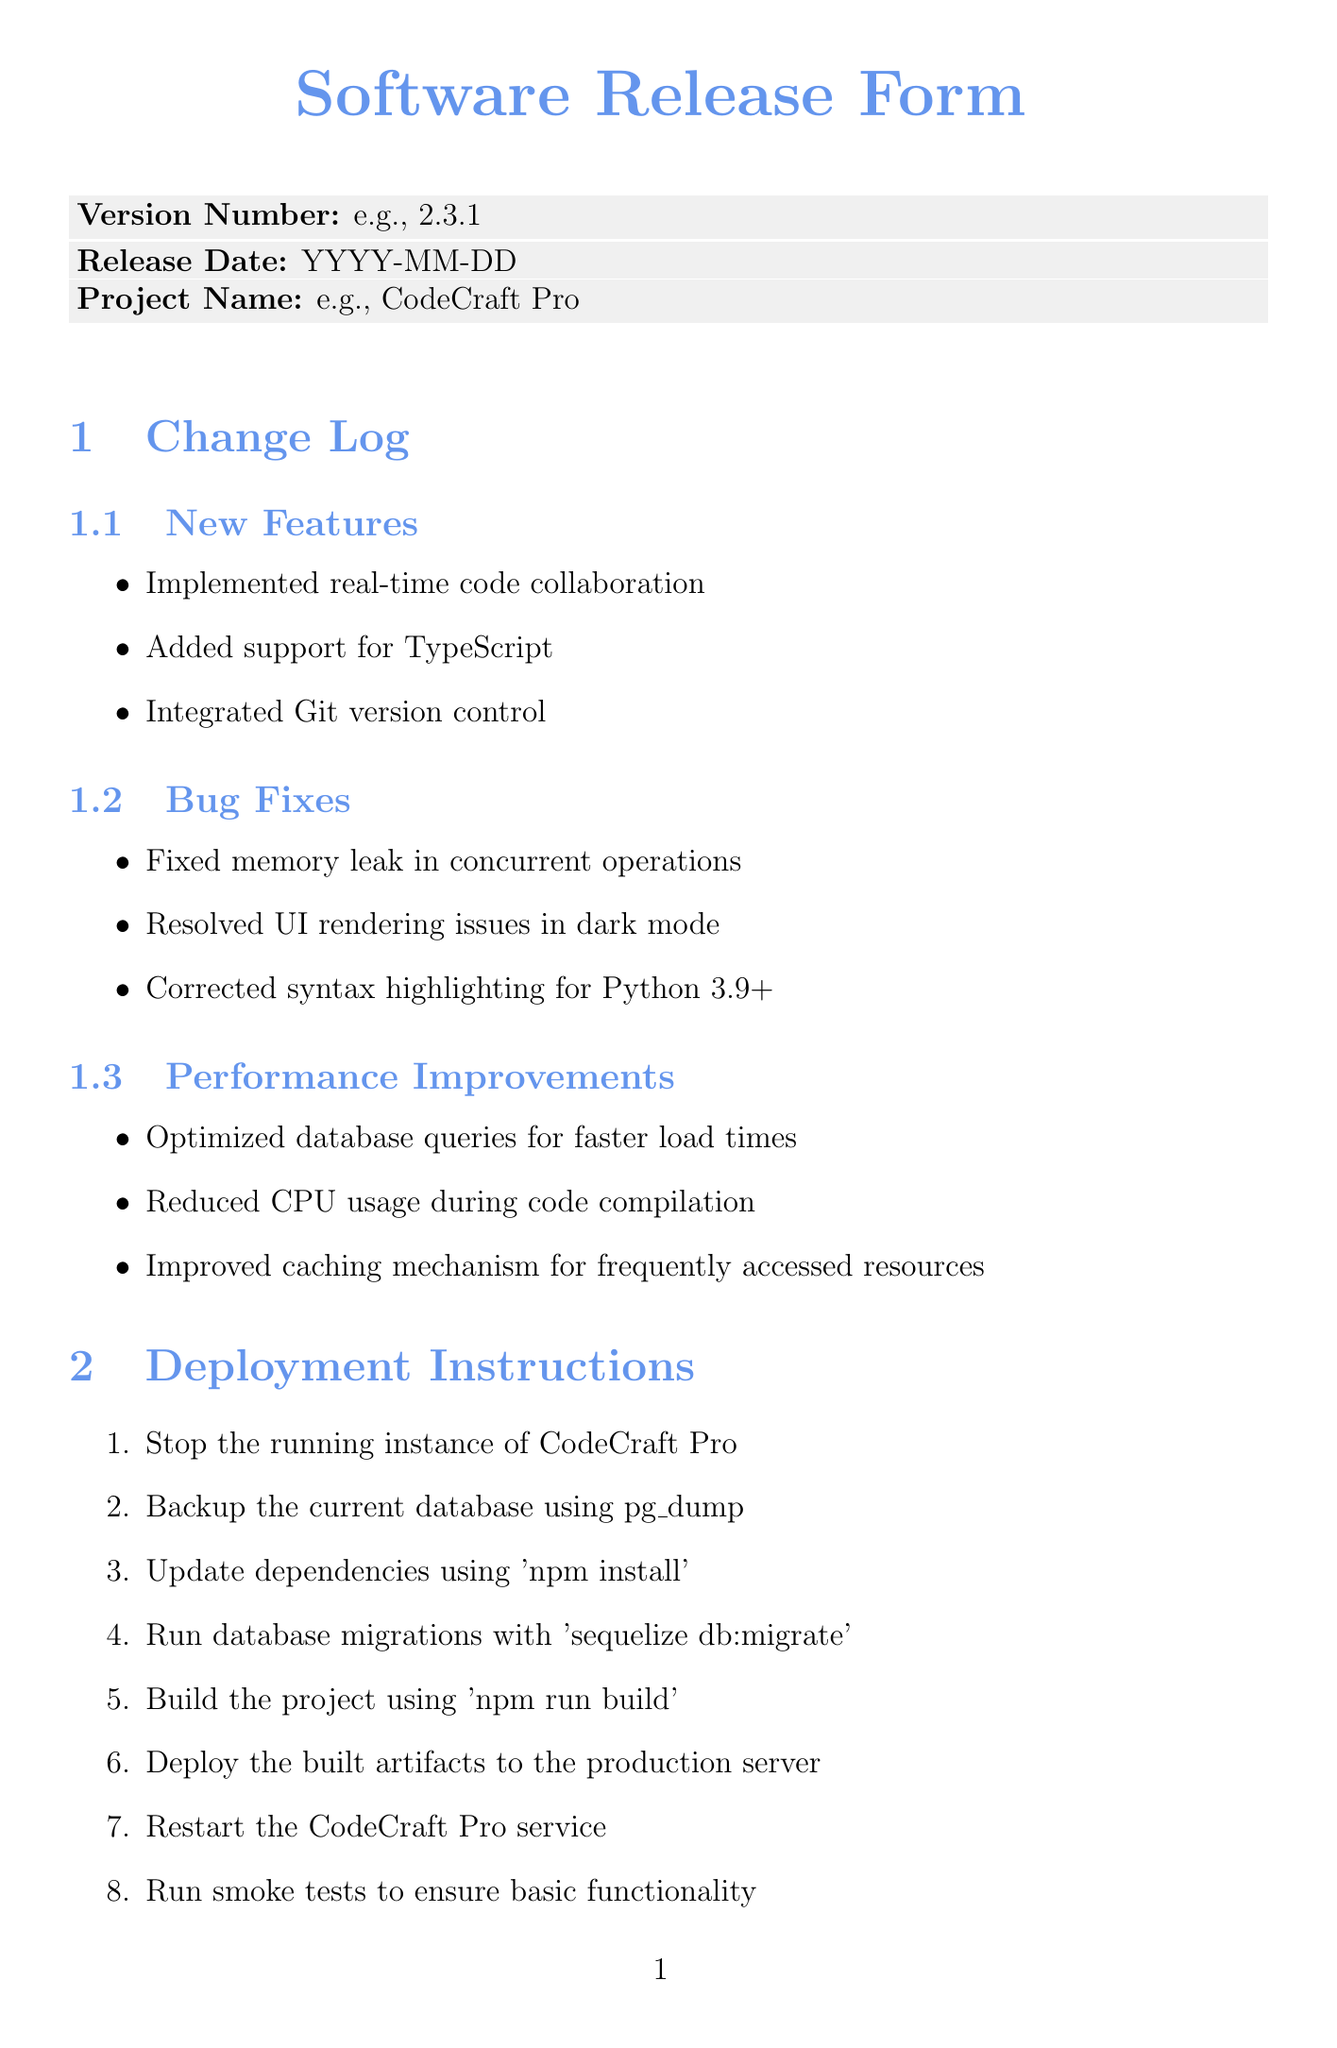what is the version number? The version number is indicated in the document, listed under the "Version Number" field.
Answer: e.g., 2.3.1 when was the release date? The release date is specified in the document, under the "Release Date" field.
Answer: YYYY-MM-DD who is the lead developer? The lead developer's name is mentioned in the "Approvals" section under the specific role.
Answer: Sarah Chen how many unit tests passed? The number of passed unit tests is found in the "Testing Results" section.
Answer: 342 what is the first step in the deployment instructions? The first step is clearly listed under the "Deployment Instructions" section.
Answer: Stop the running instance of CodeCraft Pro how many bug fixes were implemented? The number of items listed under the "Bug Fixes" subsection indicates the total fixes.
Answer: 3 what is the status of the product owner's approval? The approval status is found in the "Approvals" section for the product owner.
Answer: No how many integration tests failed? The number of failed integration tests is found in the "Testing Results" section.
Answer: 1 